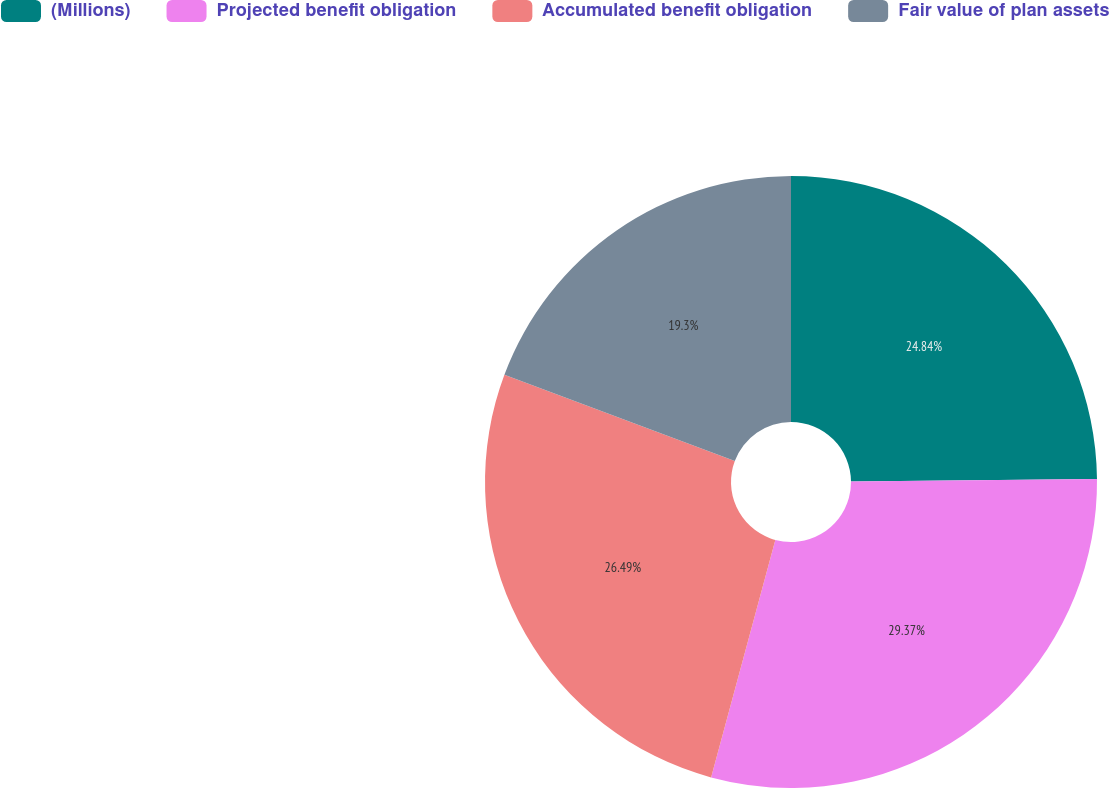Convert chart. <chart><loc_0><loc_0><loc_500><loc_500><pie_chart><fcel>(Millions)<fcel>Projected benefit obligation<fcel>Accumulated benefit obligation<fcel>Fair value of plan assets<nl><fcel>24.84%<fcel>29.36%<fcel>26.49%<fcel>19.3%<nl></chart> 